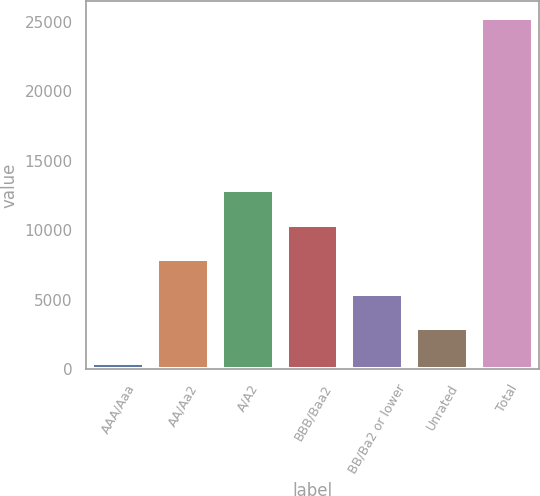Convert chart to OTSL. <chart><loc_0><loc_0><loc_500><loc_500><bar_chart><fcel>AAA/Aaa<fcel>AA/Aa2<fcel>A/A2<fcel>BBB/Baa2<fcel>BB/Ba2 or lower<fcel>Unrated<fcel>Total<nl><fcel>473<fcel>7911.2<fcel>12870<fcel>10390.6<fcel>5431.8<fcel>2952.4<fcel>25267<nl></chart> 